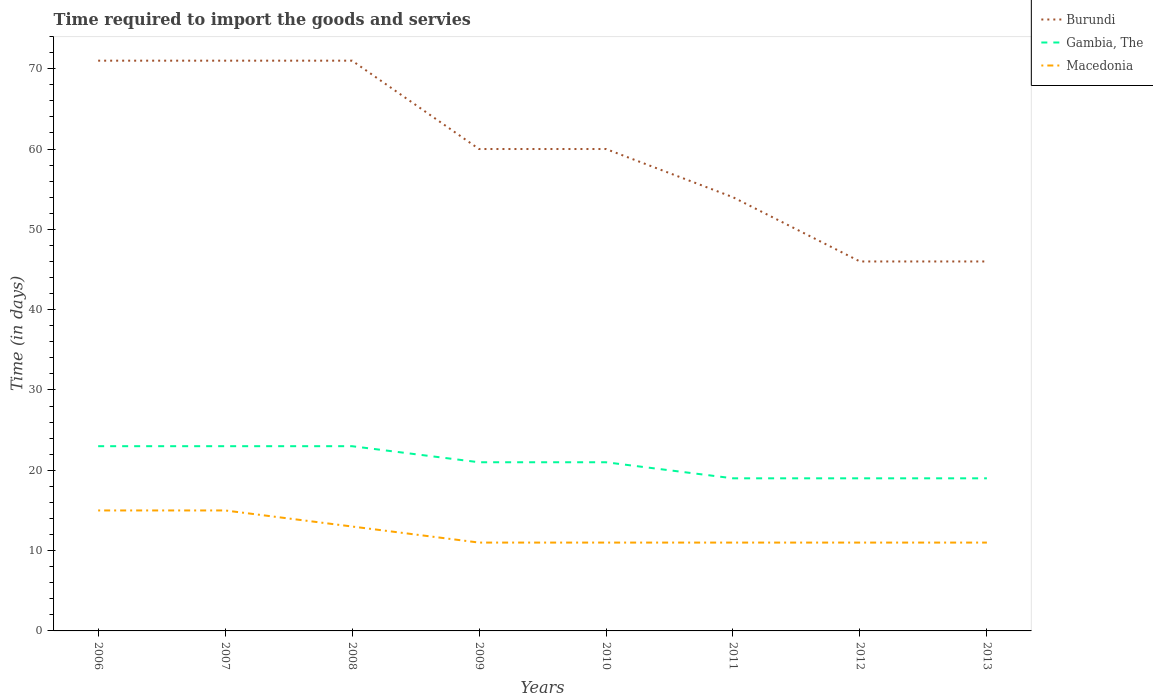Does the line corresponding to Burundi intersect with the line corresponding to Gambia, The?
Your response must be concise. No. Across all years, what is the maximum number of days required to import the goods and services in Burundi?
Offer a terse response. 46. In which year was the number of days required to import the goods and services in Burundi maximum?
Your response must be concise. 2012. What is the total number of days required to import the goods and services in Gambia, The in the graph?
Keep it short and to the point. 4. What is the difference between the highest and the second highest number of days required to import the goods and services in Burundi?
Provide a short and direct response. 25. Where does the legend appear in the graph?
Provide a short and direct response. Top right. What is the title of the graph?
Your answer should be very brief. Time required to import the goods and servies. Does "Other small states" appear as one of the legend labels in the graph?
Make the answer very short. No. What is the label or title of the Y-axis?
Offer a terse response. Time (in days). What is the Time (in days) of Gambia, The in 2006?
Provide a succinct answer. 23. What is the Time (in days) in Macedonia in 2006?
Ensure brevity in your answer.  15. What is the Time (in days) of Macedonia in 2008?
Make the answer very short. 13. What is the Time (in days) in Burundi in 2009?
Ensure brevity in your answer.  60. What is the Time (in days) in Gambia, The in 2010?
Provide a succinct answer. 21. What is the Time (in days) in Macedonia in 2010?
Provide a short and direct response. 11. What is the Time (in days) of Burundi in 2012?
Provide a succinct answer. 46. What is the Time (in days) in Burundi in 2013?
Offer a terse response. 46. Across all years, what is the maximum Time (in days) of Burundi?
Your answer should be compact. 71. Across all years, what is the maximum Time (in days) in Macedonia?
Give a very brief answer. 15. Across all years, what is the minimum Time (in days) of Gambia, The?
Your answer should be very brief. 19. Across all years, what is the minimum Time (in days) in Macedonia?
Your answer should be very brief. 11. What is the total Time (in days) in Burundi in the graph?
Give a very brief answer. 479. What is the total Time (in days) of Gambia, The in the graph?
Your answer should be compact. 168. What is the difference between the Time (in days) in Burundi in 2006 and that in 2007?
Offer a terse response. 0. What is the difference between the Time (in days) of Gambia, The in 2006 and that in 2007?
Give a very brief answer. 0. What is the difference between the Time (in days) of Macedonia in 2006 and that in 2007?
Your response must be concise. 0. What is the difference between the Time (in days) in Macedonia in 2006 and that in 2008?
Ensure brevity in your answer.  2. What is the difference between the Time (in days) of Gambia, The in 2006 and that in 2010?
Your answer should be very brief. 2. What is the difference between the Time (in days) of Macedonia in 2006 and that in 2010?
Make the answer very short. 4. What is the difference between the Time (in days) in Burundi in 2006 and that in 2011?
Provide a succinct answer. 17. What is the difference between the Time (in days) of Burundi in 2006 and that in 2012?
Offer a terse response. 25. What is the difference between the Time (in days) of Gambia, The in 2006 and that in 2012?
Offer a very short reply. 4. What is the difference between the Time (in days) of Burundi in 2006 and that in 2013?
Provide a short and direct response. 25. What is the difference between the Time (in days) in Macedonia in 2006 and that in 2013?
Your answer should be compact. 4. What is the difference between the Time (in days) in Macedonia in 2007 and that in 2008?
Offer a very short reply. 2. What is the difference between the Time (in days) of Burundi in 2007 and that in 2009?
Provide a short and direct response. 11. What is the difference between the Time (in days) in Macedonia in 2007 and that in 2009?
Offer a very short reply. 4. What is the difference between the Time (in days) in Burundi in 2007 and that in 2010?
Keep it short and to the point. 11. What is the difference between the Time (in days) in Macedonia in 2007 and that in 2010?
Your answer should be compact. 4. What is the difference between the Time (in days) of Burundi in 2007 and that in 2011?
Your answer should be compact. 17. What is the difference between the Time (in days) of Macedonia in 2007 and that in 2011?
Your answer should be compact. 4. What is the difference between the Time (in days) in Gambia, The in 2007 and that in 2012?
Keep it short and to the point. 4. What is the difference between the Time (in days) in Macedonia in 2007 and that in 2012?
Keep it short and to the point. 4. What is the difference between the Time (in days) in Burundi in 2007 and that in 2013?
Provide a short and direct response. 25. What is the difference between the Time (in days) of Gambia, The in 2007 and that in 2013?
Your answer should be compact. 4. What is the difference between the Time (in days) of Macedonia in 2008 and that in 2009?
Offer a very short reply. 2. What is the difference between the Time (in days) of Burundi in 2008 and that in 2010?
Offer a terse response. 11. What is the difference between the Time (in days) in Gambia, The in 2008 and that in 2010?
Your response must be concise. 2. What is the difference between the Time (in days) in Burundi in 2008 and that in 2011?
Keep it short and to the point. 17. What is the difference between the Time (in days) in Macedonia in 2008 and that in 2011?
Your answer should be compact. 2. What is the difference between the Time (in days) of Burundi in 2008 and that in 2012?
Offer a terse response. 25. What is the difference between the Time (in days) in Macedonia in 2008 and that in 2012?
Provide a succinct answer. 2. What is the difference between the Time (in days) of Macedonia in 2008 and that in 2013?
Make the answer very short. 2. What is the difference between the Time (in days) in Burundi in 2009 and that in 2011?
Provide a short and direct response. 6. What is the difference between the Time (in days) in Macedonia in 2009 and that in 2012?
Provide a short and direct response. 0. What is the difference between the Time (in days) in Burundi in 2009 and that in 2013?
Give a very brief answer. 14. What is the difference between the Time (in days) in Gambia, The in 2009 and that in 2013?
Provide a succinct answer. 2. What is the difference between the Time (in days) of Burundi in 2010 and that in 2011?
Provide a short and direct response. 6. What is the difference between the Time (in days) in Burundi in 2010 and that in 2012?
Your answer should be very brief. 14. What is the difference between the Time (in days) in Gambia, The in 2010 and that in 2012?
Keep it short and to the point. 2. What is the difference between the Time (in days) of Macedonia in 2010 and that in 2012?
Keep it short and to the point. 0. What is the difference between the Time (in days) of Macedonia in 2011 and that in 2012?
Provide a short and direct response. 0. What is the difference between the Time (in days) in Gambia, The in 2011 and that in 2013?
Your answer should be compact. 0. What is the difference between the Time (in days) of Macedonia in 2011 and that in 2013?
Keep it short and to the point. 0. What is the difference between the Time (in days) of Burundi in 2012 and that in 2013?
Provide a succinct answer. 0. What is the difference between the Time (in days) of Gambia, The in 2012 and that in 2013?
Offer a very short reply. 0. What is the difference between the Time (in days) of Macedonia in 2012 and that in 2013?
Keep it short and to the point. 0. What is the difference between the Time (in days) in Burundi in 2006 and the Time (in days) in Gambia, The in 2007?
Ensure brevity in your answer.  48. What is the difference between the Time (in days) in Burundi in 2006 and the Time (in days) in Macedonia in 2007?
Ensure brevity in your answer.  56. What is the difference between the Time (in days) of Burundi in 2006 and the Time (in days) of Macedonia in 2008?
Keep it short and to the point. 58. What is the difference between the Time (in days) in Gambia, The in 2006 and the Time (in days) in Macedonia in 2008?
Give a very brief answer. 10. What is the difference between the Time (in days) in Burundi in 2006 and the Time (in days) in Macedonia in 2009?
Make the answer very short. 60. What is the difference between the Time (in days) of Gambia, The in 2006 and the Time (in days) of Macedonia in 2010?
Ensure brevity in your answer.  12. What is the difference between the Time (in days) of Burundi in 2006 and the Time (in days) of Gambia, The in 2011?
Offer a terse response. 52. What is the difference between the Time (in days) in Burundi in 2006 and the Time (in days) in Macedonia in 2011?
Provide a succinct answer. 60. What is the difference between the Time (in days) of Gambia, The in 2006 and the Time (in days) of Macedonia in 2011?
Provide a short and direct response. 12. What is the difference between the Time (in days) of Burundi in 2006 and the Time (in days) of Macedonia in 2012?
Your response must be concise. 60. What is the difference between the Time (in days) in Gambia, The in 2006 and the Time (in days) in Macedonia in 2012?
Ensure brevity in your answer.  12. What is the difference between the Time (in days) of Gambia, The in 2006 and the Time (in days) of Macedonia in 2013?
Your answer should be very brief. 12. What is the difference between the Time (in days) of Burundi in 2007 and the Time (in days) of Macedonia in 2008?
Give a very brief answer. 58. What is the difference between the Time (in days) of Gambia, The in 2007 and the Time (in days) of Macedonia in 2008?
Give a very brief answer. 10. What is the difference between the Time (in days) of Burundi in 2007 and the Time (in days) of Macedonia in 2010?
Offer a terse response. 60. What is the difference between the Time (in days) in Gambia, The in 2007 and the Time (in days) in Macedonia in 2010?
Your answer should be compact. 12. What is the difference between the Time (in days) of Burundi in 2007 and the Time (in days) of Macedonia in 2011?
Ensure brevity in your answer.  60. What is the difference between the Time (in days) of Gambia, The in 2007 and the Time (in days) of Macedonia in 2011?
Your answer should be compact. 12. What is the difference between the Time (in days) in Burundi in 2007 and the Time (in days) in Gambia, The in 2012?
Your answer should be very brief. 52. What is the difference between the Time (in days) of Gambia, The in 2007 and the Time (in days) of Macedonia in 2012?
Offer a terse response. 12. What is the difference between the Time (in days) in Burundi in 2007 and the Time (in days) in Gambia, The in 2013?
Give a very brief answer. 52. What is the difference between the Time (in days) of Gambia, The in 2007 and the Time (in days) of Macedonia in 2013?
Give a very brief answer. 12. What is the difference between the Time (in days) in Burundi in 2008 and the Time (in days) in Gambia, The in 2009?
Keep it short and to the point. 50. What is the difference between the Time (in days) in Burundi in 2008 and the Time (in days) in Macedonia in 2009?
Provide a succinct answer. 60. What is the difference between the Time (in days) of Gambia, The in 2008 and the Time (in days) of Macedonia in 2009?
Offer a very short reply. 12. What is the difference between the Time (in days) of Burundi in 2008 and the Time (in days) of Macedonia in 2010?
Provide a short and direct response. 60. What is the difference between the Time (in days) of Burundi in 2008 and the Time (in days) of Gambia, The in 2011?
Ensure brevity in your answer.  52. What is the difference between the Time (in days) of Burundi in 2008 and the Time (in days) of Macedonia in 2011?
Keep it short and to the point. 60. What is the difference between the Time (in days) of Burundi in 2008 and the Time (in days) of Gambia, The in 2012?
Give a very brief answer. 52. What is the difference between the Time (in days) of Gambia, The in 2008 and the Time (in days) of Macedonia in 2012?
Offer a terse response. 12. What is the difference between the Time (in days) of Burundi in 2008 and the Time (in days) of Gambia, The in 2013?
Offer a very short reply. 52. What is the difference between the Time (in days) in Burundi in 2009 and the Time (in days) in Gambia, The in 2010?
Keep it short and to the point. 39. What is the difference between the Time (in days) of Burundi in 2009 and the Time (in days) of Macedonia in 2010?
Give a very brief answer. 49. What is the difference between the Time (in days) of Burundi in 2009 and the Time (in days) of Gambia, The in 2011?
Offer a very short reply. 41. What is the difference between the Time (in days) of Burundi in 2009 and the Time (in days) of Gambia, The in 2012?
Offer a terse response. 41. What is the difference between the Time (in days) of Burundi in 2009 and the Time (in days) of Macedonia in 2012?
Make the answer very short. 49. What is the difference between the Time (in days) in Burundi in 2009 and the Time (in days) in Macedonia in 2013?
Make the answer very short. 49. What is the difference between the Time (in days) in Gambia, The in 2009 and the Time (in days) in Macedonia in 2013?
Keep it short and to the point. 10. What is the difference between the Time (in days) of Burundi in 2010 and the Time (in days) of Gambia, The in 2011?
Give a very brief answer. 41. What is the difference between the Time (in days) in Burundi in 2010 and the Time (in days) in Macedonia in 2011?
Your answer should be very brief. 49. What is the difference between the Time (in days) in Gambia, The in 2010 and the Time (in days) in Macedonia in 2011?
Your response must be concise. 10. What is the difference between the Time (in days) of Burundi in 2010 and the Time (in days) of Macedonia in 2012?
Your answer should be compact. 49. What is the difference between the Time (in days) in Burundi in 2010 and the Time (in days) in Macedonia in 2013?
Give a very brief answer. 49. What is the difference between the Time (in days) of Gambia, The in 2010 and the Time (in days) of Macedonia in 2013?
Your response must be concise. 10. What is the difference between the Time (in days) in Burundi in 2011 and the Time (in days) in Macedonia in 2012?
Your answer should be compact. 43. What is the difference between the Time (in days) of Gambia, The in 2011 and the Time (in days) of Macedonia in 2012?
Keep it short and to the point. 8. What is the difference between the Time (in days) of Burundi in 2011 and the Time (in days) of Gambia, The in 2013?
Ensure brevity in your answer.  35. What is the difference between the Time (in days) of Burundi in 2011 and the Time (in days) of Macedonia in 2013?
Your answer should be compact. 43. What is the difference between the Time (in days) of Burundi in 2012 and the Time (in days) of Gambia, The in 2013?
Provide a succinct answer. 27. What is the difference between the Time (in days) in Burundi in 2012 and the Time (in days) in Macedonia in 2013?
Provide a succinct answer. 35. What is the difference between the Time (in days) of Gambia, The in 2012 and the Time (in days) of Macedonia in 2013?
Offer a terse response. 8. What is the average Time (in days) of Burundi per year?
Your response must be concise. 59.88. What is the average Time (in days) in Gambia, The per year?
Give a very brief answer. 21. What is the average Time (in days) of Macedonia per year?
Keep it short and to the point. 12.25. In the year 2006, what is the difference between the Time (in days) in Burundi and Time (in days) in Macedonia?
Provide a succinct answer. 56. In the year 2006, what is the difference between the Time (in days) in Gambia, The and Time (in days) in Macedonia?
Ensure brevity in your answer.  8. In the year 2007, what is the difference between the Time (in days) in Burundi and Time (in days) in Gambia, The?
Provide a short and direct response. 48. In the year 2007, what is the difference between the Time (in days) of Burundi and Time (in days) of Macedonia?
Offer a very short reply. 56. In the year 2007, what is the difference between the Time (in days) in Gambia, The and Time (in days) in Macedonia?
Give a very brief answer. 8. In the year 2008, what is the difference between the Time (in days) of Burundi and Time (in days) of Gambia, The?
Keep it short and to the point. 48. In the year 2008, what is the difference between the Time (in days) in Gambia, The and Time (in days) in Macedonia?
Offer a very short reply. 10. In the year 2009, what is the difference between the Time (in days) in Burundi and Time (in days) in Gambia, The?
Offer a terse response. 39. In the year 2009, what is the difference between the Time (in days) of Burundi and Time (in days) of Macedonia?
Give a very brief answer. 49. In the year 2009, what is the difference between the Time (in days) in Gambia, The and Time (in days) in Macedonia?
Give a very brief answer. 10. In the year 2010, what is the difference between the Time (in days) in Burundi and Time (in days) in Gambia, The?
Offer a very short reply. 39. In the year 2010, what is the difference between the Time (in days) in Burundi and Time (in days) in Macedonia?
Give a very brief answer. 49. In the year 2011, what is the difference between the Time (in days) of Burundi and Time (in days) of Macedonia?
Your answer should be compact. 43. In the year 2012, what is the difference between the Time (in days) of Burundi and Time (in days) of Gambia, The?
Provide a short and direct response. 27. In the year 2012, what is the difference between the Time (in days) in Gambia, The and Time (in days) in Macedonia?
Provide a succinct answer. 8. In the year 2013, what is the difference between the Time (in days) of Burundi and Time (in days) of Macedonia?
Offer a terse response. 35. What is the ratio of the Time (in days) in Burundi in 2006 to that in 2007?
Make the answer very short. 1. What is the ratio of the Time (in days) of Macedonia in 2006 to that in 2007?
Provide a short and direct response. 1. What is the ratio of the Time (in days) in Gambia, The in 2006 to that in 2008?
Keep it short and to the point. 1. What is the ratio of the Time (in days) in Macedonia in 2006 to that in 2008?
Provide a short and direct response. 1.15. What is the ratio of the Time (in days) in Burundi in 2006 to that in 2009?
Offer a terse response. 1.18. What is the ratio of the Time (in days) in Gambia, The in 2006 to that in 2009?
Make the answer very short. 1.1. What is the ratio of the Time (in days) in Macedonia in 2006 to that in 2009?
Your response must be concise. 1.36. What is the ratio of the Time (in days) in Burundi in 2006 to that in 2010?
Your answer should be very brief. 1.18. What is the ratio of the Time (in days) in Gambia, The in 2006 to that in 2010?
Make the answer very short. 1.1. What is the ratio of the Time (in days) in Macedonia in 2006 to that in 2010?
Provide a short and direct response. 1.36. What is the ratio of the Time (in days) of Burundi in 2006 to that in 2011?
Your answer should be compact. 1.31. What is the ratio of the Time (in days) of Gambia, The in 2006 to that in 2011?
Provide a succinct answer. 1.21. What is the ratio of the Time (in days) of Macedonia in 2006 to that in 2011?
Offer a terse response. 1.36. What is the ratio of the Time (in days) of Burundi in 2006 to that in 2012?
Keep it short and to the point. 1.54. What is the ratio of the Time (in days) of Gambia, The in 2006 to that in 2012?
Offer a very short reply. 1.21. What is the ratio of the Time (in days) in Macedonia in 2006 to that in 2012?
Your answer should be very brief. 1.36. What is the ratio of the Time (in days) in Burundi in 2006 to that in 2013?
Your answer should be very brief. 1.54. What is the ratio of the Time (in days) of Gambia, The in 2006 to that in 2013?
Keep it short and to the point. 1.21. What is the ratio of the Time (in days) in Macedonia in 2006 to that in 2013?
Ensure brevity in your answer.  1.36. What is the ratio of the Time (in days) of Gambia, The in 2007 to that in 2008?
Make the answer very short. 1. What is the ratio of the Time (in days) of Macedonia in 2007 to that in 2008?
Your answer should be very brief. 1.15. What is the ratio of the Time (in days) in Burundi in 2007 to that in 2009?
Provide a succinct answer. 1.18. What is the ratio of the Time (in days) in Gambia, The in 2007 to that in 2009?
Ensure brevity in your answer.  1.1. What is the ratio of the Time (in days) in Macedonia in 2007 to that in 2009?
Make the answer very short. 1.36. What is the ratio of the Time (in days) of Burundi in 2007 to that in 2010?
Provide a succinct answer. 1.18. What is the ratio of the Time (in days) in Gambia, The in 2007 to that in 2010?
Keep it short and to the point. 1.1. What is the ratio of the Time (in days) in Macedonia in 2007 to that in 2010?
Ensure brevity in your answer.  1.36. What is the ratio of the Time (in days) of Burundi in 2007 to that in 2011?
Keep it short and to the point. 1.31. What is the ratio of the Time (in days) of Gambia, The in 2007 to that in 2011?
Your answer should be very brief. 1.21. What is the ratio of the Time (in days) of Macedonia in 2007 to that in 2011?
Offer a terse response. 1.36. What is the ratio of the Time (in days) in Burundi in 2007 to that in 2012?
Provide a short and direct response. 1.54. What is the ratio of the Time (in days) of Gambia, The in 2007 to that in 2012?
Your response must be concise. 1.21. What is the ratio of the Time (in days) in Macedonia in 2007 to that in 2012?
Give a very brief answer. 1.36. What is the ratio of the Time (in days) of Burundi in 2007 to that in 2013?
Make the answer very short. 1.54. What is the ratio of the Time (in days) in Gambia, The in 2007 to that in 2013?
Your answer should be compact. 1.21. What is the ratio of the Time (in days) of Macedonia in 2007 to that in 2013?
Offer a terse response. 1.36. What is the ratio of the Time (in days) in Burundi in 2008 to that in 2009?
Offer a terse response. 1.18. What is the ratio of the Time (in days) in Gambia, The in 2008 to that in 2009?
Your answer should be very brief. 1.1. What is the ratio of the Time (in days) in Macedonia in 2008 to that in 2009?
Your answer should be compact. 1.18. What is the ratio of the Time (in days) of Burundi in 2008 to that in 2010?
Provide a succinct answer. 1.18. What is the ratio of the Time (in days) of Gambia, The in 2008 to that in 2010?
Give a very brief answer. 1.1. What is the ratio of the Time (in days) of Macedonia in 2008 to that in 2010?
Your response must be concise. 1.18. What is the ratio of the Time (in days) of Burundi in 2008 to that in 2011?
Give a very brief answer. 1.31. What is the ratio of the Time (in days) of Gambia, The in 2008 to that in 2011?
Your response must be concise. 1.21. What is the ratio of the Time (in days) of Macedonia in 2008 to that in 2011?
Your answer should be compact. 1.18. What is the ratio of the Time (in days) in Burundi in 2008 to that in 2012?
Give a very brief answer. 1.54. What is the ratio of the Time (in days) of Gambia, The in 2008 to that in 2012?
Make the answer very short. 1.21. What is the ratio of the Time (in days) in Macedonia in 2008 to that in 2012?
Give a very brief answer. 1.18. What is the ratio of the Time (in days) of Burundi in 2008 to that in 2013?
Ensure brevity in your answer.  1.54. What is the ratio of the Time (in days) of Gambia, The in 2008 to that in 2013?
Give a very brief answer. 1.21. What is the ratio of the Time (in days) of Macedonia in 2008 to that in 2013?
Offer a very short reply. 1.18. What is the ratio of the Time (in days) in Burundi in 2009 to that in 2010?
Your response must be concise. 1. What is the ratio of the Time (in days) in Macedonia in 2009 to that in 2010?
Provide a succinct answer. 1. What is the ratio of the Time (in days) in Burundi in 2009 to that in 2011?
Offer a very short reply. 1.11. What is the ratio of the Time (in days) of Gambia, The in 2009 to that in 2011?
Offer a very short reply. 1.11. What is the ratio of the Time (in days) in Macedonia in 2009 to that in 2011?
Make the answer very short. 1. What is the ratio of the Time (in days) in Burundi in 2009 to that in 2012?
Give a very brief answer. 1.3. What is the ratio of the Time (in days) in Gambia, The in 2009 to that in 2012?
Your answer should be very brief. 1.11. What is the ratio of the Time (in days) in Macedonia in 2009 to that in 2012?
Offer a very short reply. 1. What is the ratio of the Time (in days) in Burundi in 2009 to that in 2013?
Your answer should be very brief. 1.3. What is the ratio of the Time (in days) in Gambia, The in 2009 to that in 2013?
Provide a short and direct response. 1.11. What is the ratio of the Time (in days) in Macedonia in 2009 to that in 2013?
Your answer should be compact. 1. What is the ratio of the Time (in days) of Gambia, The in 2010 to that in 2011?
Give a very brief answer. 1.11. What is the ratio of the Time (in days) of Macedonia in 2010 to that in 2011?
Your answer should be compact. 1. What is the ratio of the Time (in days) in Burundi in 2010 to that in 2012?
Your response must be concise. 1.3. What is the ratio of the Time (in days) of Gambia, The in 2010 to that in 2012?
Ensure brevity in your answer.  1.11. What is the ratio of the Time (in days) in Macedonia in 2010 to that in 2012?
Ensure brevity in your answer.  1. What is the ratio of the Time (in days) in Burundi in 2010 to that in 2013?
Provide a succinct answer. 1.3. What is the ratio of the Time (in days) of Gambia, The in 2010 to that in 2013?
Offer a terse response. 1.11. What is the ratio of the Time (in days) of Macedonia in 2010 to that in 2013?
Give a very brief answer. 1. What is the ratio of the Time (in days) in Burundi in 2011 to that in 2012?
Provide a short and direct response. 1.17. What is the ratio of the Time (in days) in Burundi in 2011 to that in 2013?
Provide a succinct answer. 1.17. What is the ratio of the Time (in days) in Burundi in 2012 to that in 2013?
Provide a short and direct response. 1. What is the ratio of the Time (in days) of Macedonia in 2012 to that in 2013?
Provide a short and direct response. 1. What is the difference between the highest and the second highest Time (in days) in Macedonia?
Offer a terse response. 0. What is the difference between the highest and the lowest Time (in days) of Gambia, The?
Give a very brief answer. 4. 